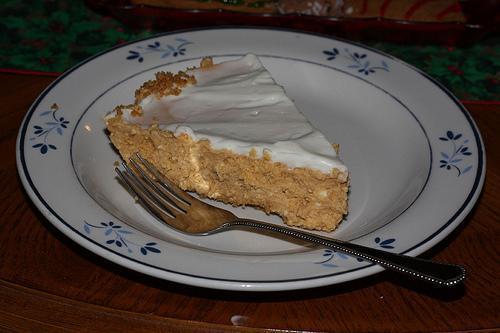How many forks are in the picture?
Give a very brief answer. 1. How many pieces of pie are in the picture?
Give a very brief answer. 1. How many flower patterns are on the plate?
Give a very brief answer. 6. How many tines are on the fork?
Give a very brief answer. 4. 